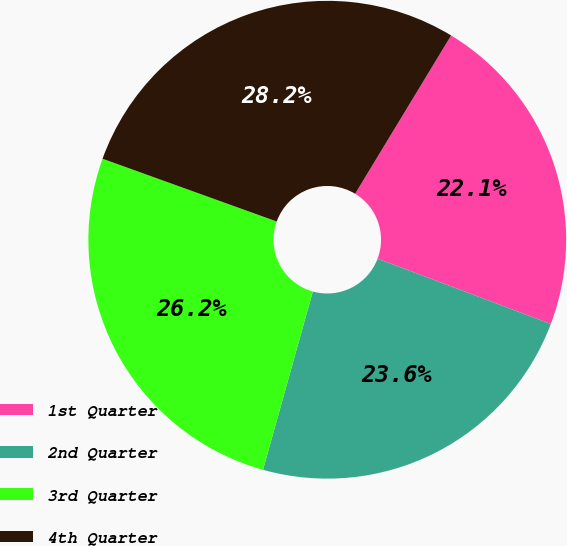Convert chart to OTSL. <chart><loc_0><loc_0><loc_500><loc_500><pie_chart><fcel>1st Quarter<fcel>2nd Quarter<fcel>3rd Quarter<fcel>4th Quarter<nl><fcel>22.06%<fcel>23.6%<fcel>26.17%<fcel>28.17%<nl></chart> 